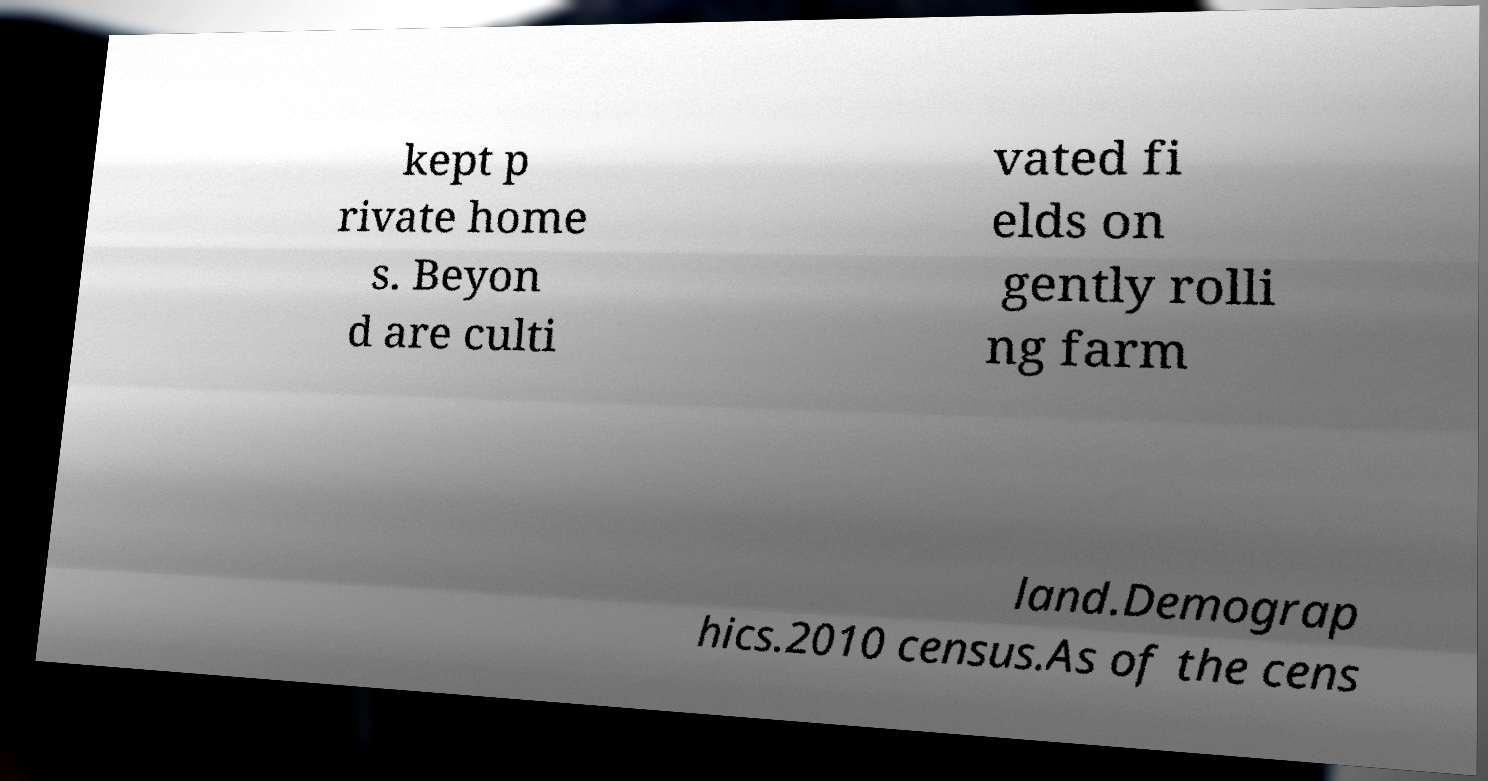Could you extract and type out the text from this image? kept p rivate home s. Beyon d are culti vated fi elds on gently rolli ng farm land.Demograp hics.2010 census.As of the cens 